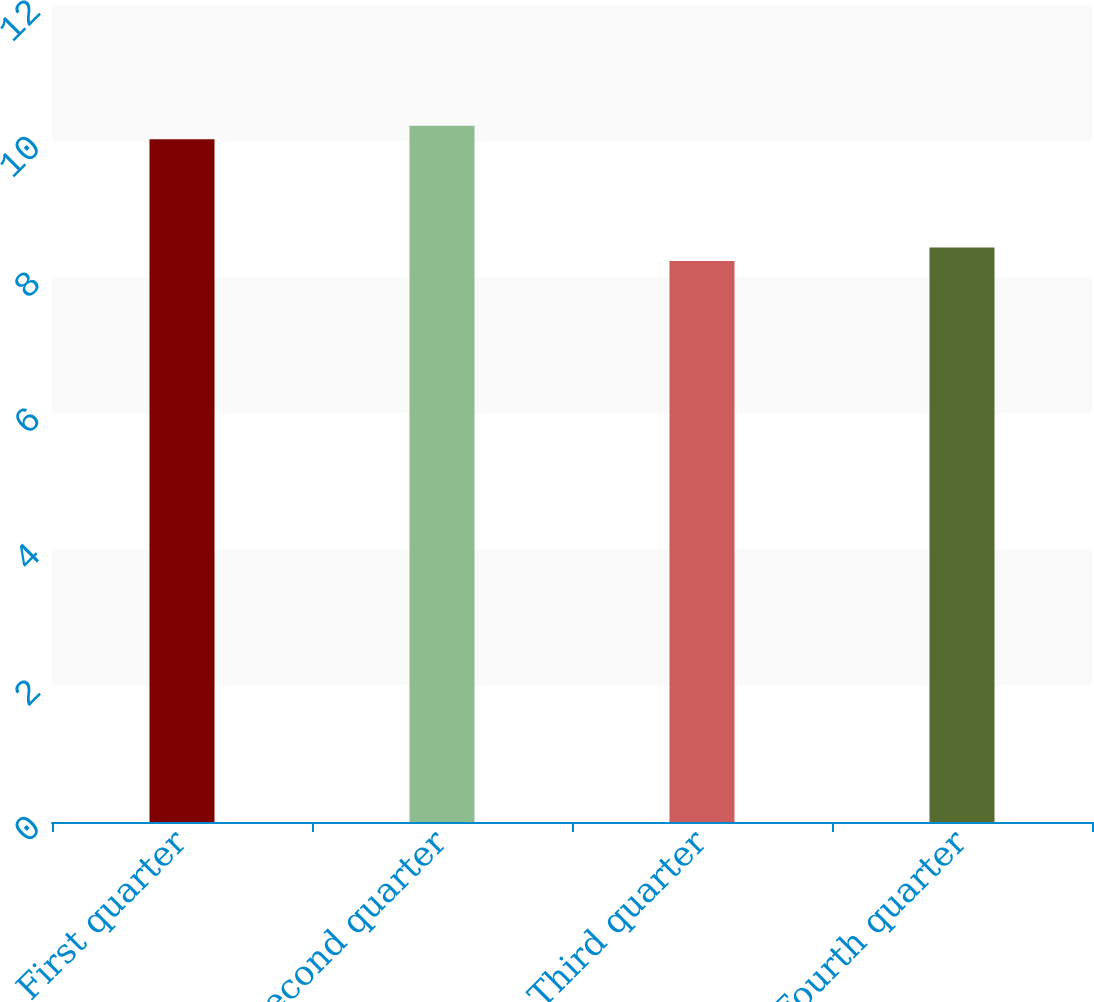Convert chart to OTSL. <chart><loc_0><loc_0><loc_500><loc_500><bar_chart><fcel>First quarter<fcel>Second quarter<fcel>Third quarter<fcel>Fourth quarter<nl><fcel>10.04<fcel>10.24<fcel>8.25<fcel>8.45<nl></chart> 